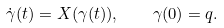<formula> <loc_0><loc_0><loc_500><loc_500>\dot { \gamma } ( t ) = X ( \gamma ( t ) ) , \quad \gamma ( 0 ) = q .</formula> 